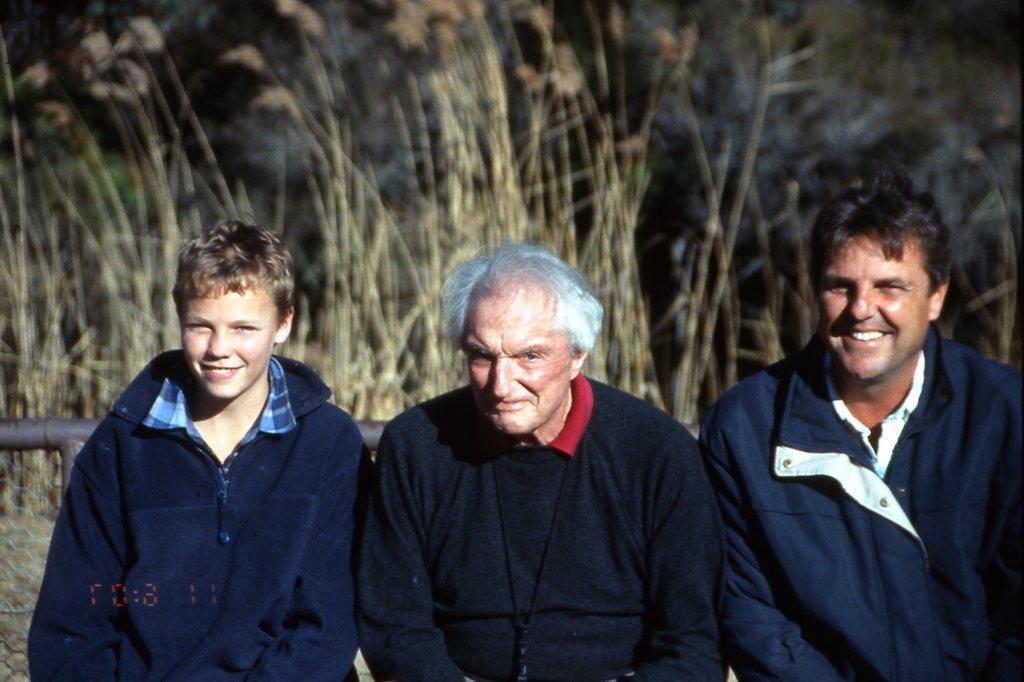Please provide a concise description of this image. In the image there are three persons standing. Behind them there is rod. And also there is dry grass in the background. 